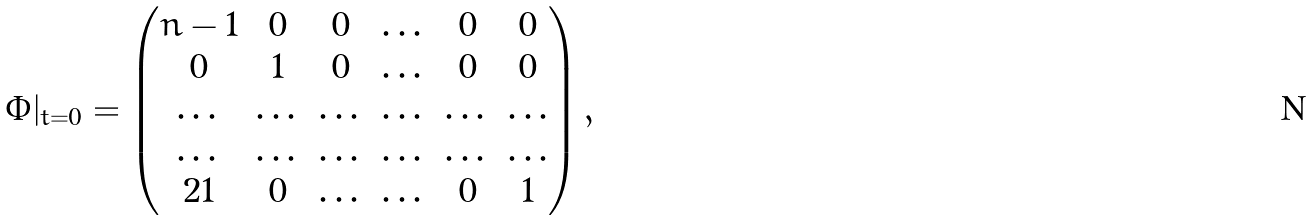<formula> <loc_0><loc_0><loc_500><loc_500>\Phi | _ { t = 0 } = \begin{pmatrix} n - 1 & 0 & 0 & \dots & 0 & 0 \\ 0 & 1 & 0 & \dots & 0 & 0 \\ \dots & \dots & \dots & \dots & \dots & \dots \\ \dots & \dots & \dots & \dots & \dots & \dots \\ 2 1 & 0 & \dots & \dots & 0 & 1 \end{pmatrix} ,</formula> 